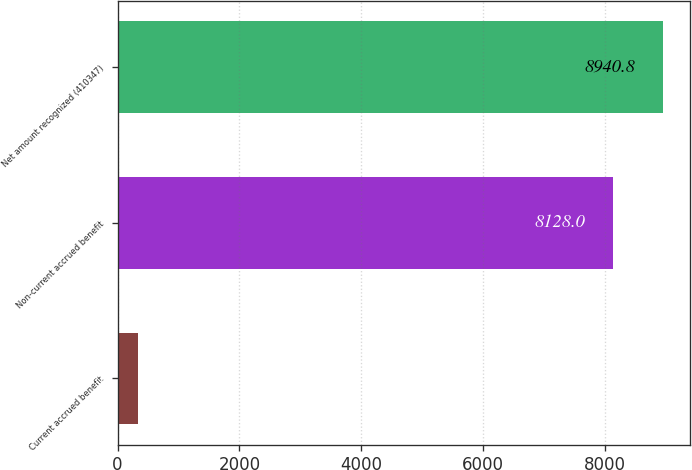Convert chart. <chart><loc_0><loc_0><loc_500><loc_500><bar_chart><fcel>Current accrued benefit<fcel>Non-current accrued benefit<fcel>Net amount recognized (410347)<nl><fcel>333<fcel>8128<fcel>8940.8<nl></chart> 